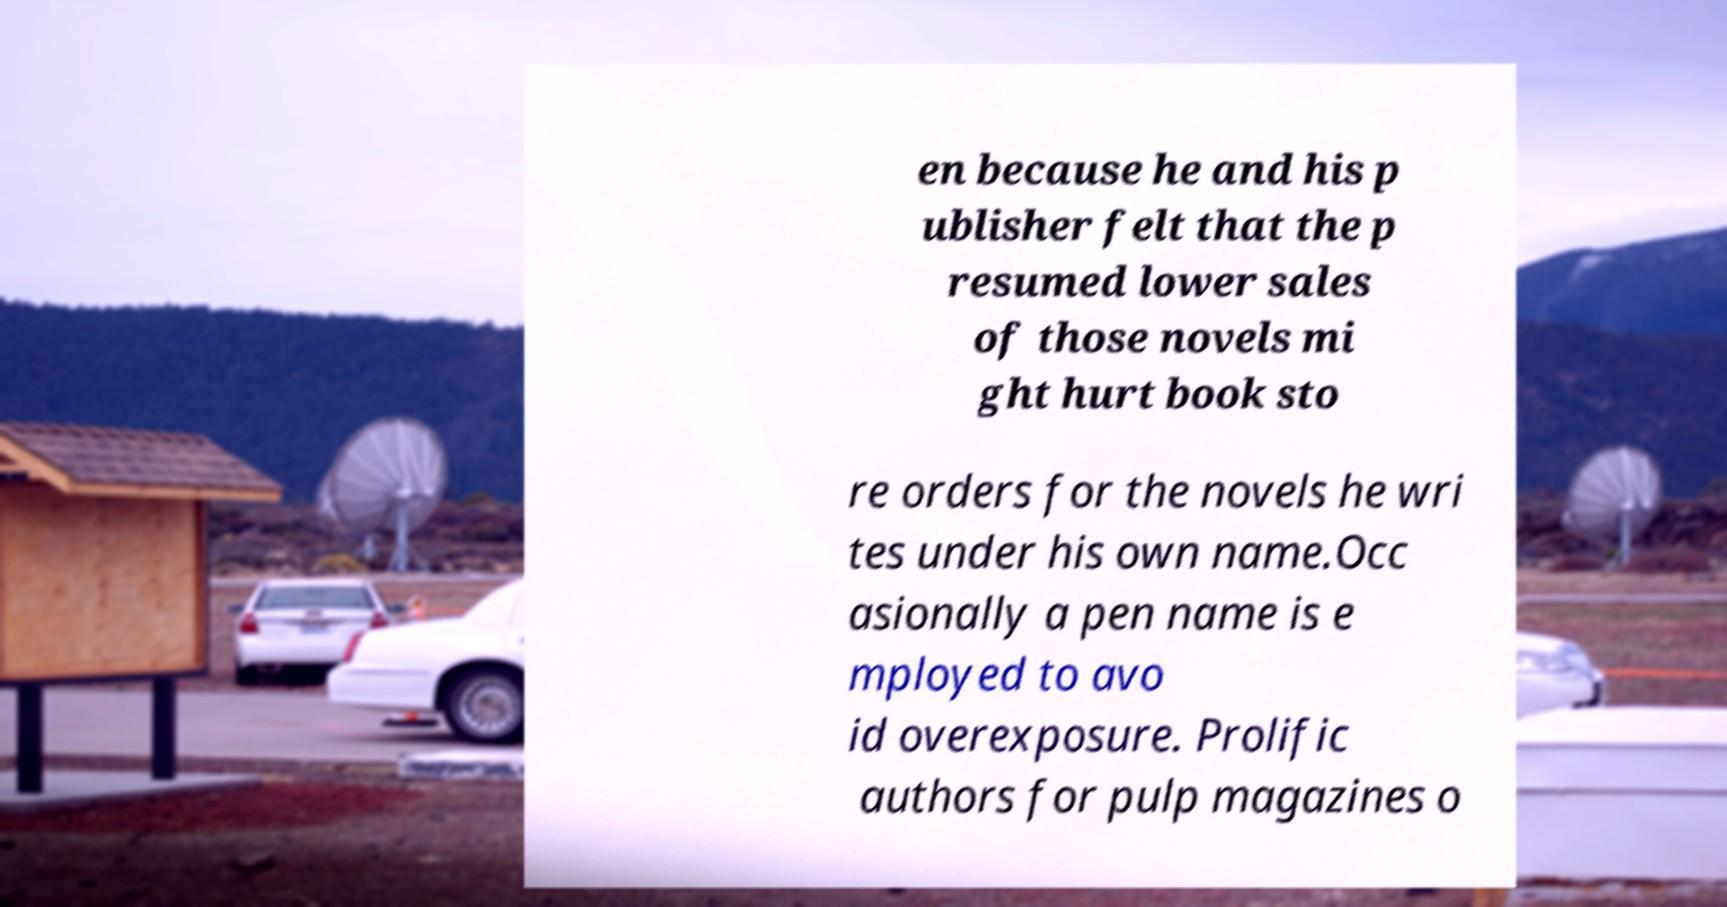Can you read and provide the text displayed in the image?This photo seems to have some interesting text. Can you extract and type it out for me? en because he and his p ublisher felt that the p resumed lower sales of those novels mi ght hurt book sto re orders for the novels he wri tes under his own name.Occ asionally a pen name is e mployed to avo id overexposure. Prolific authors for pulp magazines o 